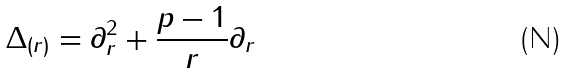<formula> <loc_0><loc_0><loc_500><loc_500>\Delta _ { ( r ) } = \partial _ { r } ^ { 2 } + \frac { p - 1 } { r } \partial _ { r }</formula> 